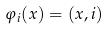Convert formula to latex. <formula><loc_0><loc_0><loc_500><loc_500>\varphi _ { i } ( x ) = ( x , i )</formula> 